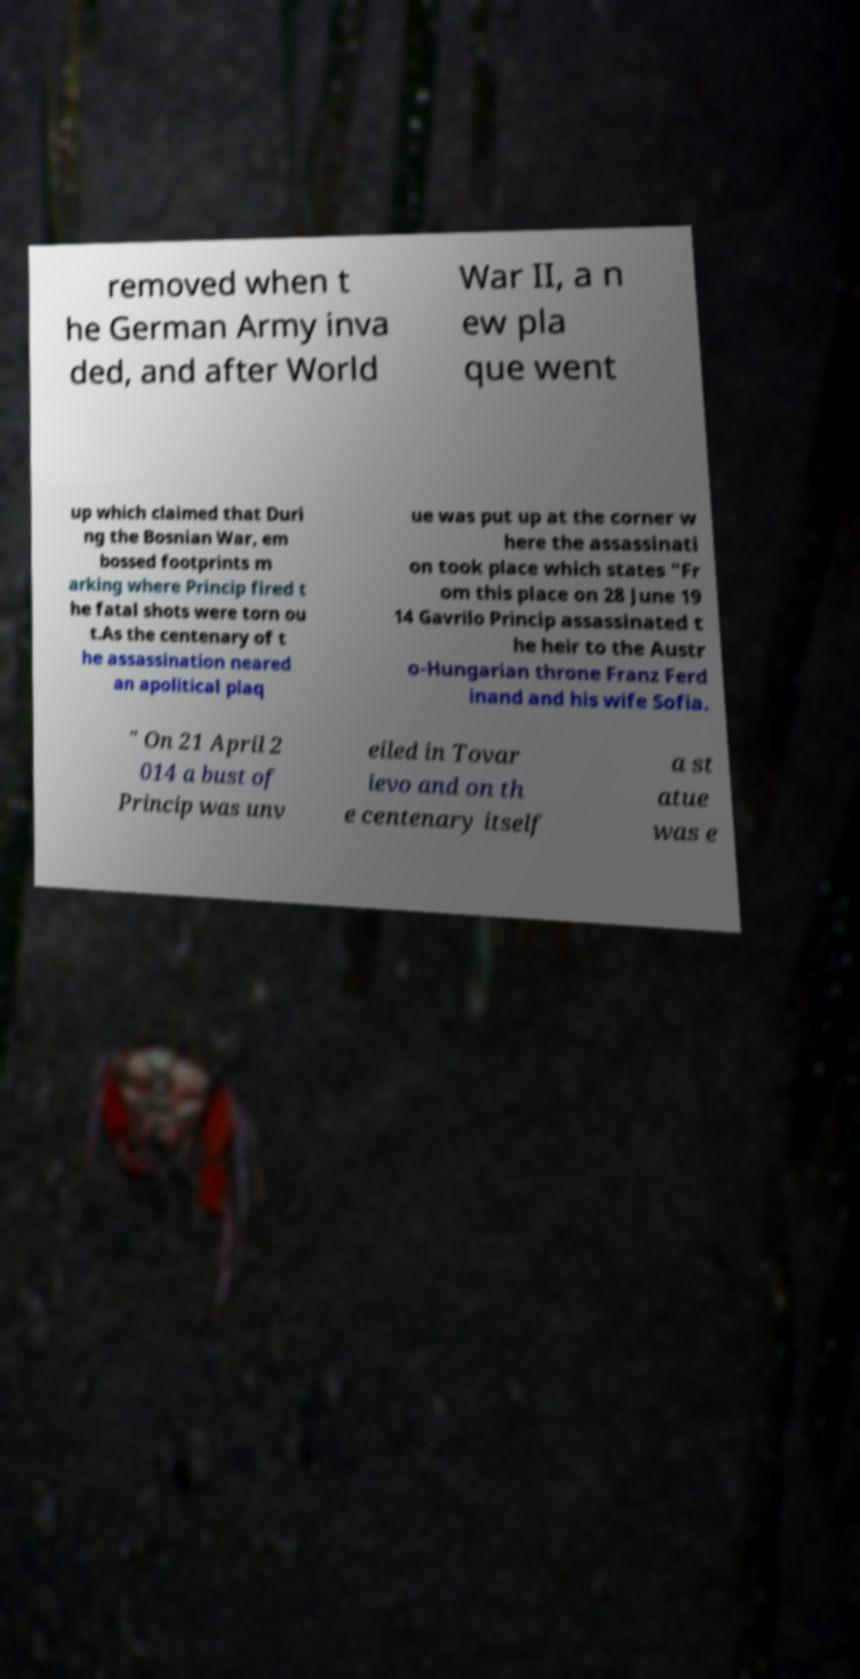Please read and relay the text visible in this image. What does it say? removed when t he German Army inva ded, and after World War II, a n ew pla que went up which claimed that Duri ng the Bosnian War, em bossed footprints m arking where Princip fired t he fatal shots were torn ou t.As the centenary of t he assassination neared an apolitical plaq ue was put up at the corner w here the assassinati on took place which states "Fr om this place on 28 June 19 14 Gavrilo Princip assassinated t he heir to the Austr o-Hungarian throne Franz Ferd inand and his wife Sofia. " On 21 April 2 014 a bust of Princip was unv eiled in Tovar ievo and on th e centenary itself a st atue was e 